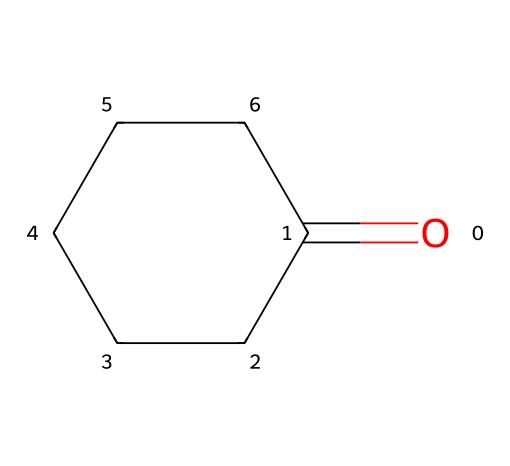What is the molecular formula of cyclohexanone? The SMILES representation O=C1CCCCC1 indicates there is one carbonyl group (C=O) and six carbon atoms in a ring structure. Therefore, the molecular formula can be derived as C6H10O, where the two hydrogen atoms removed for the ketone and the cyclic structure is accounted for.
Answer: C6H10O How many carbon atoms are present in cyclohexanone? By analyzing the structure from the SMILES notation, we can see there is a cyclohexane ring composed of six carbon atoms. Therefore, there are six carbon atoms present in the compound.
Answer: 6 What functional group is present in cyclohexanone? The presence of the carbonyl group (C=O) is the key feature identified within the SMILES notation. This characteristic is definitive of ketones, which contain a carbonyl group bonded to two carbon atoms.
Answer: carbonyl group What type of compound is cyclohexanone? Cyclohexanone has a carbonyl functional group that is not at the terminal ends of the carbon chain, categorizing it specifically as a ketone. This can be directly interpreted from its structural representation.
Answer: ketone Does cyclohexanone have any rings in its structure? The SMILES representation O=C1CCCCC1 indicates the presence of a cyclohexane ring structure. The '1' symbol denotes that the first and last carbon atoms are connected, forming a cyclic structure.
Answer: yes How many hydrogen atoms are in cyclohexanone? In the given structure, cyclohexanone has six carbon atoms and one carbonyl group that eliminates two hydrogen atoms from the corresponding saturated structure of cyclohexane (C6H12), resulting in a total of ten hydrogen atoms.
Answer: 10 